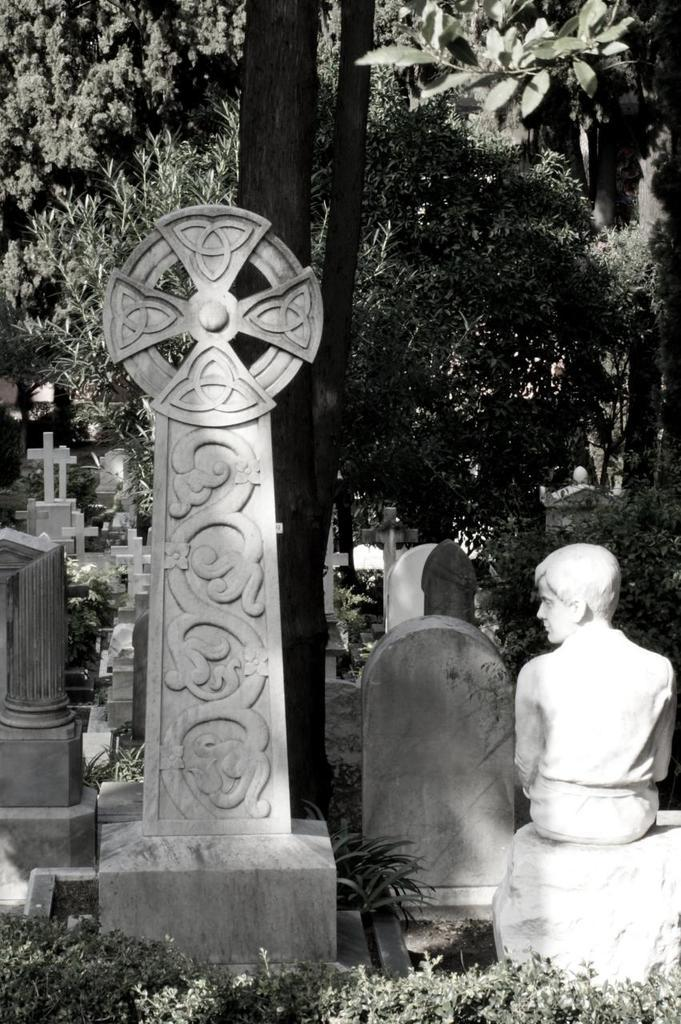What type of structures can be seen in the image? There are graves and a memorial in the image. What can be seen in the background of the image? There are trees in the background of the image. What religious symbols are present in the image? Christianity symbols are present in the image. What type of soup is being served at the gravesite in the image? There is no soup present in the image; it features graves, a memorial, trees, and Christianity symbols. 